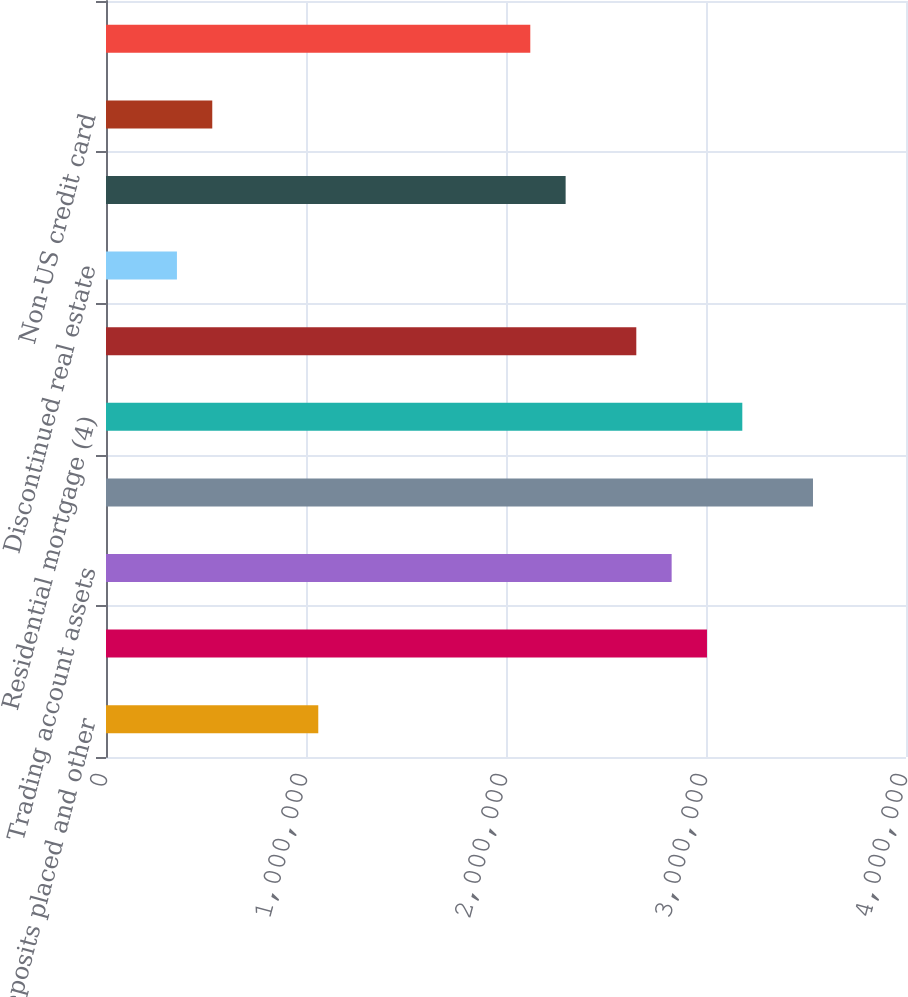<chart> <loc_0><loc_0><loc_500><loc_500><bar_chart><fcel>Time deposits placed and other<fcel>Federal funds sold and<fcel>Trading account assets<fcel>Debt securities (2)<fcel>Residential mortgage (4)<fcel>Home equity<fcel>Discontinued real estate<fcel>US credit card<fcel>Non-US credit card<fcel>Direct/Indirect consumer (5)<nl><fcel>1.06138e+06<fcel>3.00488e+06<fcel>2.8282e+06<fcel>3.53492e+06<fcel>3.18156e+06<fcel>2.65151e+06<fcel>354650<fcel>2.29815e+06<fcel>531332<fcel>2.12147e+06<nl></chart> 